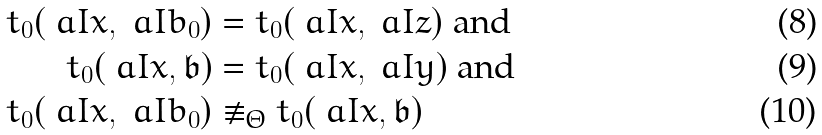Convert formula to latex. <formula><loc_0><loc_0><loc_500><loc_500>t _ { 0 } ( \ a I { x } , \ a I { b } _ { 0 } ) & = t _ { 0 } ( \ a I { x } , \ a I { z } ) \text { and} \\ t _ { 0 } ( \ a I { x } , \mathfrak { b } ) & = t _ { 0 } ( \ a I { x } , \ a I { y } ) \text { and} \\ t _ { 0 } ( \ a I { x } , \ a I { b } _ { 0 } ) & \not \equiv _ { \Theta } t _ { 0 } ( \ a I { x } , \mathfrak { b } )</formula> 